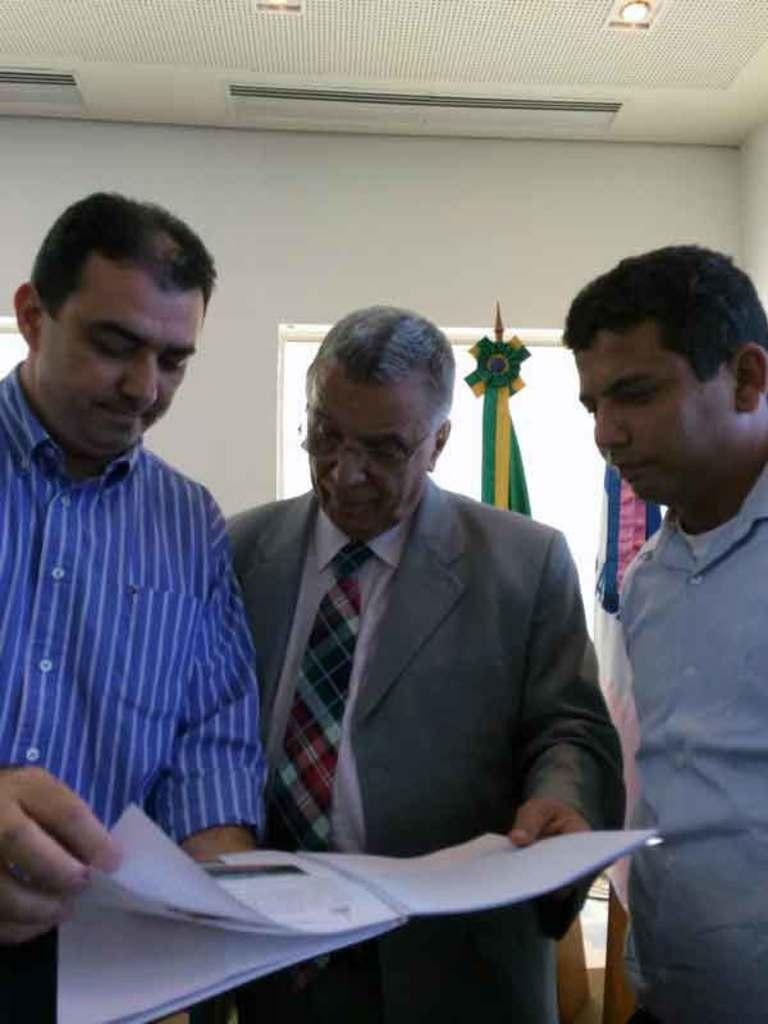How many people are in the image? There are three men in the image. What are the men doing in the image? The men are standing and looking at a book. What can be seen on the wall behind the men? There is a window on the wall behind the men. What is on the window? The window has a ribbon on it. What is visible on the ceiling in the image? There are lights on the ceiling in the image. What type of suit is the man in the middle wearing in the image? There is no information about the men's clothing in the image, so it cannot be determined if any of them are wearing a suit. 